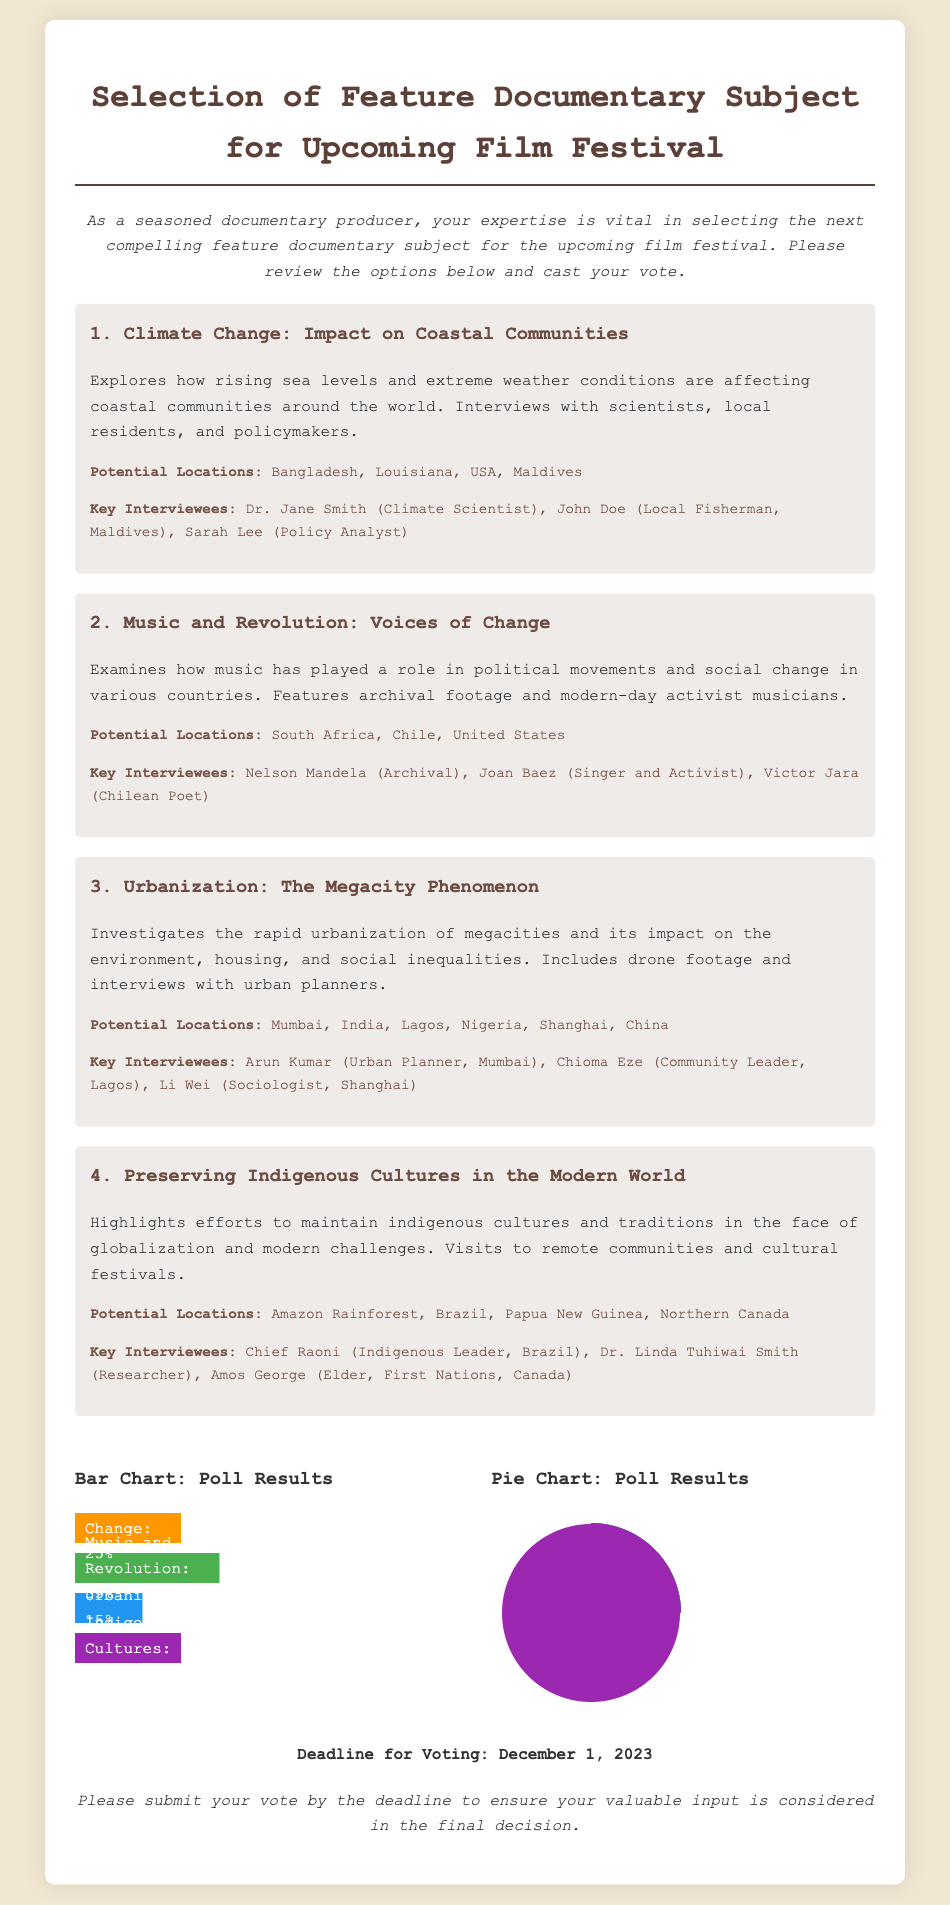What is the title of the document? The document's title is presented prominently at the top, providing the main subject of the content.
Answer: Selection of Feature Documentary Subject for Upcoming Film Festival What is the voting deadline? The document specifies the deadline for voting, making it clear when responses must be submitted.
Answer: December 1, 2023 Which subject received the highest percentage of votes? The bar chart displays the voting results, indicating which documentary subject was the most favored based on percentages.
Answer: Music and Revolution How many potential locations are listed for the "Urbanization" documentary? The document includes a short description that lists locations for each proposed subject; counting them provides the answer.
Answer: 3 Who is a key interviewee for the "Preserving Indigenous Cultures" option? The document states key interviewees for each subject, allowing for easy identification.
Answer: Chief Raoni What percentage of votes did "Climate Change" receive? The bar chart visually represents the voting percentages for each subject, allowing for a direct answer.
Answer: 25% Which documentary examines the role of music in political movements? The description provides a clear context for each subject, making it straightforward to identify the relevant option.
Answer: Music and Revolution How many interviewees are listed for the "Music and Revolution" subject? The document provides a list of key interviewees for each subject, which can be counted for the answer.
Answer: 3 